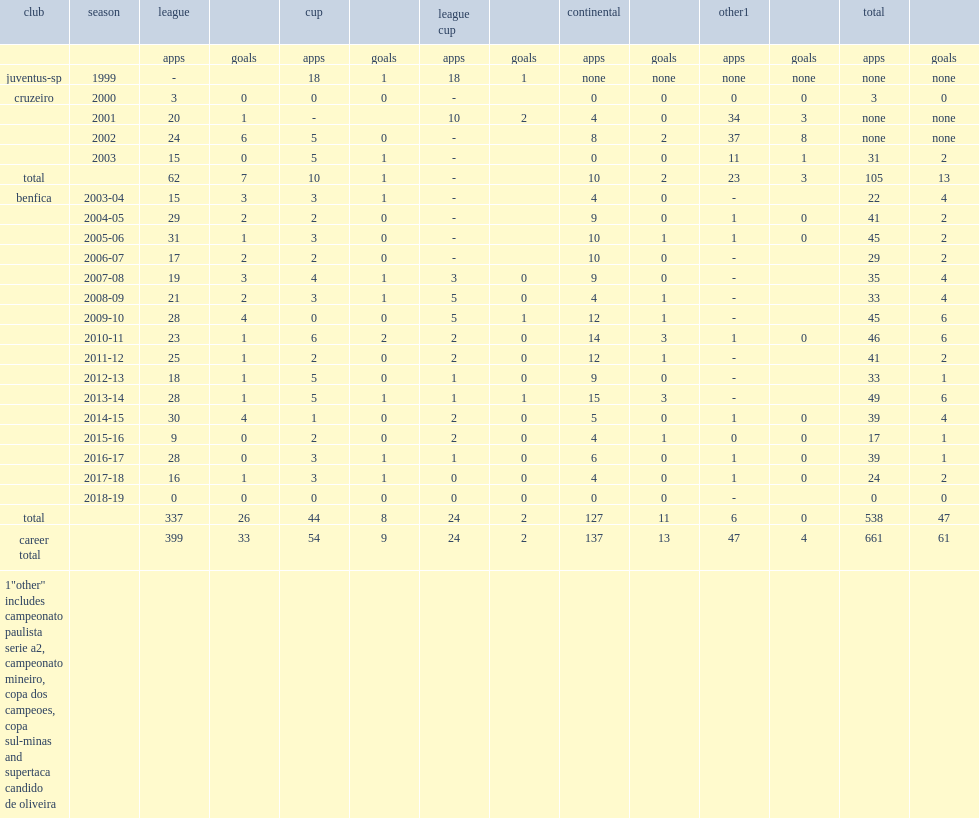How many matches did luisao play for benfica totally? 538.0. 